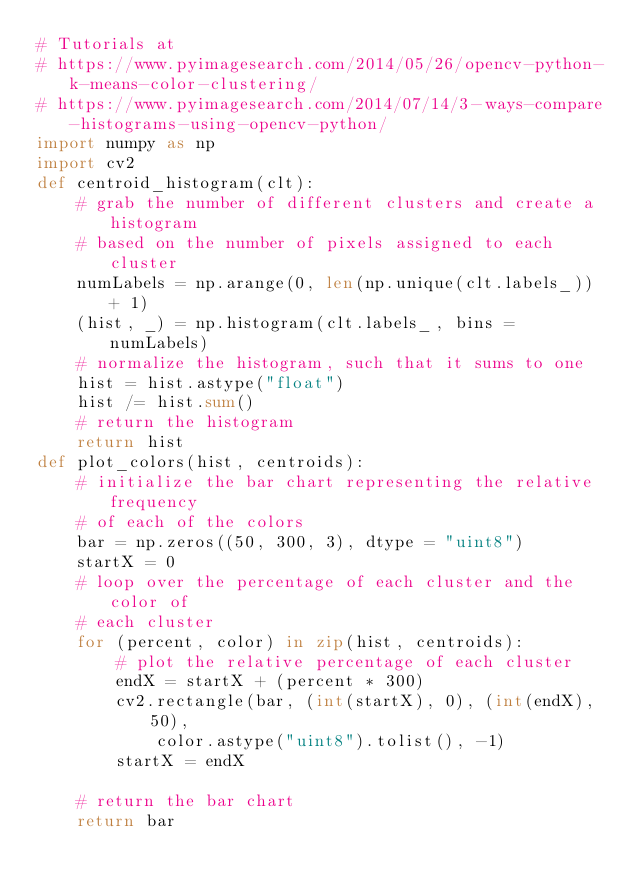Convert code to text. <code><loc_0><loc_0><loc_500><loc_500><_Python_># Tutorials at
# https://www.pyimagesearch.com/2014/05/26/opencv-python-k-means-color-clustering/
# https://www.pyimagesearch.com/2014/07/14/3-ways-compare-histograms-using-opencv-python/
import numpy as np
import cv2
def centroid_histogram(clt):
	# grab the number of different clusters and create a histogram
	# based on the number of pixels assigned to each cluster
	numLabels = np.arange(0, len(np.unique(clt.labels_)) + 1)
	(hist, _) = np.histogram(clt.labels_, bins = numLabels)
	# normalize the histogram, such that it sums to one
	hist = hist.astype("float")
	hist /= hist.sum()
	# return the histogram
	return hist
def plot_colors(hist, centroids):
	# initialize the bar chart representing the relative frequency
	# of each of the colors
	bar = np.zeros((50, 300, 3), dtype = "uint8")
	startX = 0
	# loop over the percentage of each cluster and the color of
	# each cluster
	for (percent, color) in zip(hist, centroids):
		# plot the relative percentage of each cluster
		endX = startX + (percent * 300)
		cv2.rectangle(bar, (int(startX), 0), (int(endX), 50),
			color.astype("uint8").tolist(), -1)
		startX = endX
	
	# return the bar chart
	return bar</code> 